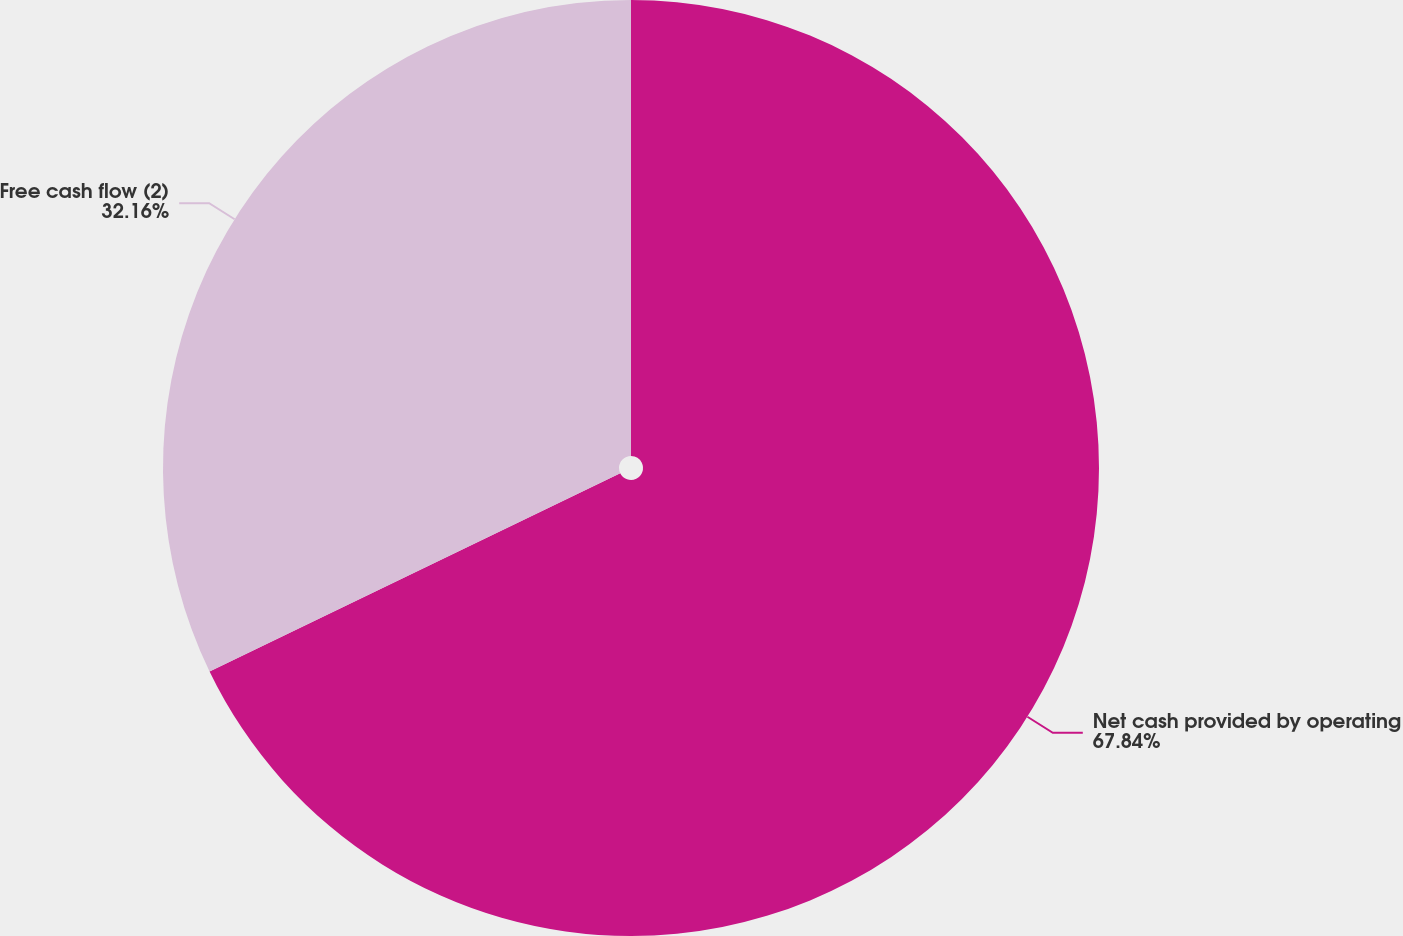Convert chart to OTSL. <chart><loc_0><loc_0><loc_500><loc_500><pie_chart><fcel>Net cash provided by operating<fcel>Free cash flow (2)<nl><fcel>67.84%<fcel>32.16%<nl></chart> 